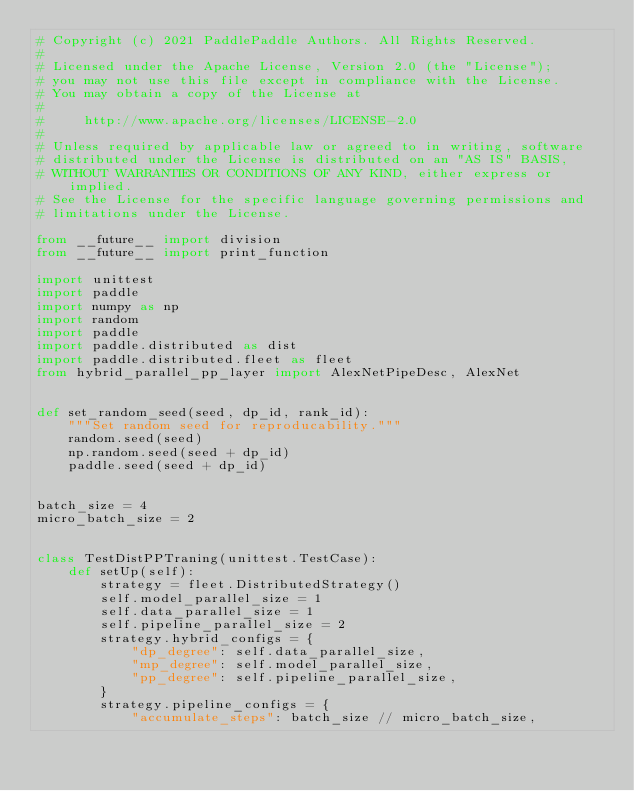Convert code to text. <code><loc_0><loc_0><loc_500><loc_500><_Python_># Copyright (c) 2021 PaddlePaddle Authors. All Rights Reserved.
#
# Licensed under the Apache License, Version 2.0 (the "License");
# you may not use this file except in compliance with the License.
# You may obtain a copy of the License at
#
#     http://www.apache.org/licenses/LICENSE-2.0
#
# Unless required by applicable law or agreed to in writing, software
# distributed under the License is distributed on an "AS IS" BASIS,
# WITHOUT WARRANTIES OR CONDITIONS OF ANY KIND, either express or implied.
# See the License for the specific language governing permissions and
# limitations under the License.

from __future__ import division
from __future__ import print_function

import unittest
import paddle
import numpy as np
import random
import paddle
import paddle.distributed as dist
import paddle.distributed.fleet as fleet
from hybrid_parallel_pp_layer import AlexNetPipeDesc, AlexNet


def set_random_seed(seed, dp_id, rank_id):
    """Set random seed for reproducability."""
    random.seed(seed)
    np.random.seed(seed + dp_id)
    paddle.seed(seed + dp_id)


batch_size = 4
micro_batch_size = 2


class TestDistPPTraning(unittest.TestCase):
    def setUp(self):
        strategy = fleet.DistributedStrategy()
        self.model_parallel_size = 1
        self.data_parallel_size = 1
        self.pipeline_parallel_size = 2
        strategy.hybrid_configs = {
            "dp_degree": self.data_parallel_size,
            "mp_degree": self.model_parallel_size,
            "pp_degree": self.pipeline_parallel_size,
        }
        strategy.pipeline_configs = {
            "accumulate_steps": batch_size // micro_batch_size,</code> 